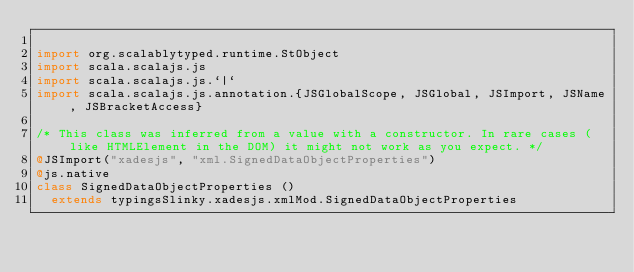Convert code to text. <code><loc_0><loc_0><loc_500><loc_500><_Scala_>
import org.scalablytyped.runtime.StObject
import scala.scalajs.js
import scala.scalajs.js.`|`
import scala.scalajs.js.annotation.{JSGlobalScope, JSGlobal, JSImport, JSName, JSBracketAccess}

/* This class was inferred from a value with a constructor. In rare cases (like HTMLElement in the DOM) it might not work as you expect. */
@JSImport("xadesjs", "xml.SignedDataObjectProperties")
@js.native
class SignedDataObjectProperties ()
  extends typingsSlinky.xadesjs.xmlMod.SignedDataObjectProperties
</code> 